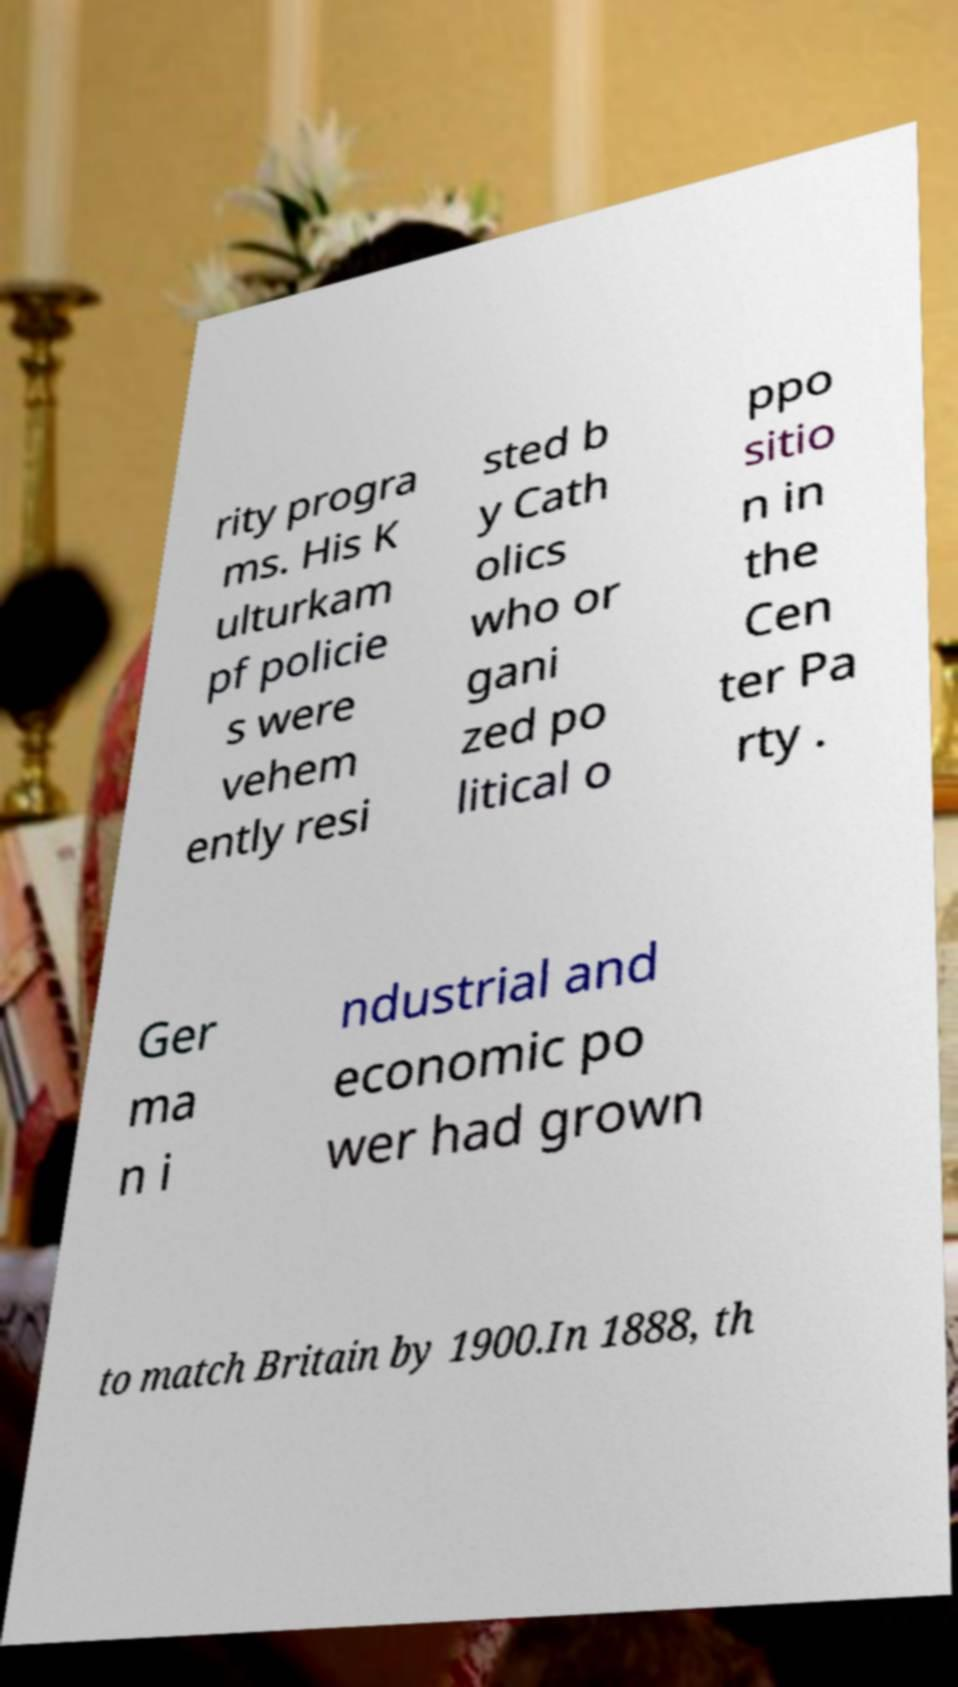Can you read and provide the text displayed in the image?This photo seems to have some interesting text. Can you extract and type it out for me? rity progra ms. His K ulturkam pf policie s were vehem ently resi sted b y Cath olics who or gani zed po litical o ppo sitio n in the Cen ter Pa rty . Ger ma n i ndustrial and economic po wer had grown to match Britain by 1900.In 1888, th 